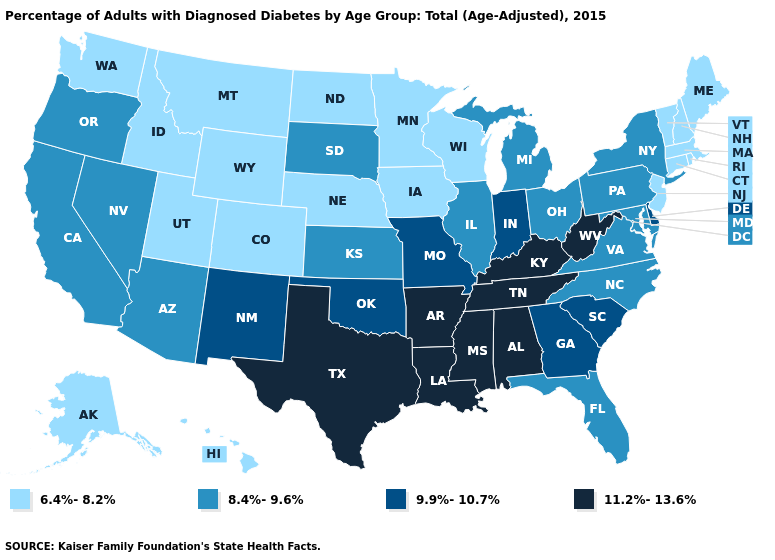Name the states that have a value in the range 8.4%-9.6%?
Quick response, please. Arizona, California, Florida, Illinois, Kansas, Maryland, Michigan, Nevada, New York, North Carolina, Ohio, Oregon, Pennsylvania, South Dakota, Virginia. What is the value of South Carolina?
Keep it brief. 9.9%-10.7%. Which states hav the highest value in the MidWest?
Quick response, please. Indiana, Missouri. Does Missouri have the same value as Indiana?
Answer briefly. Yes. Which states have the lowest value in the USA?
Be succinct. Alaska, Colorado, Connecticut, Hawaii, Idaho, Iowa, Maine, Massachusetts, Minnesota, Montana, Nebraska, New Hampshire, New Jersey, North Dakota, Rhode Island, Utah, Vermont, Washington, Wisconsin, Wyoming. Does Georgia have the highest value in the South?
Write a very short answer. No. Among the states that border Nebraska , does Wyoming have the lowest value?
Write a very short answer. Yes. Name the states that have a value in the range 11.2%-13.6%?
Keep it brief. Alabama, Arkansas, Kentucky, Louisiana, Mississippi, Tennessee, Texas, West Virginia. What is the value of Maine?
Answer briefly. 6.4%-8.2%. What is the highest value in states that border Connecticut?
Give a very brief answer. 8.4%-9.6%. Which states hav the highest value in the MidWest?
Concise answer only. Indiana, Missouri. Does the map have missing data?
Keep it brief. No. What is the value of California?
Be succinct. 8.4%-9.6%. Which states have the lowest value in the USA?
Answer briefly. Alaska, Colorado, Connecticut, Hawaii, Idaho, Iowa, Maine, Massachusetts, Minnesota, Montana, Nebraska, New Hampshire, New Jersey, North Dakota, Rhode Island, Utah, Vermont, Washington, Wisconsin, Wyoming. What is the value of Utah?
Quick response, please. 6.4%-8.2%. 